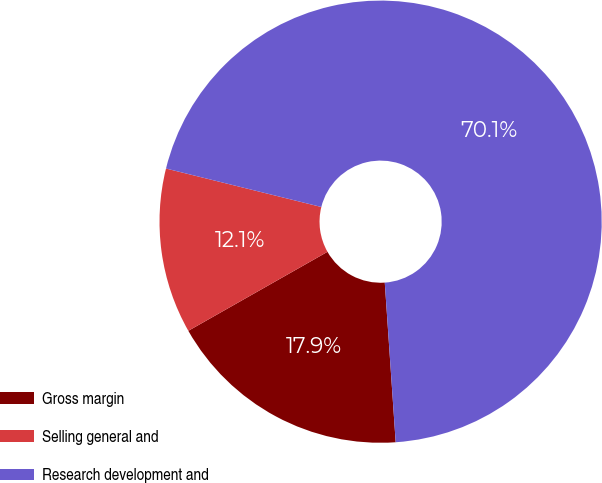Convert chart to OTSL. <chart><loc_0><loc_0><loc_500><loc_500><pie_chart><fcel>Gross margin<fcel>Selling general and<fcel>Research development and<nl><fcel>17.87%<fcel>12.08%<fcel>70.05%<nl></chart> 